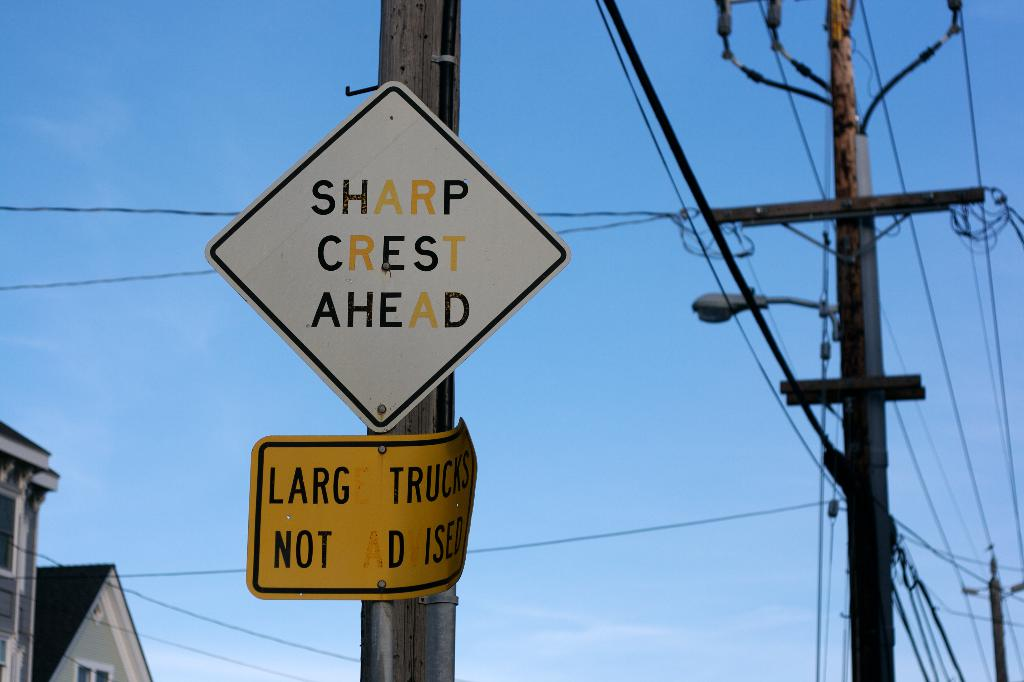What might be the significance of the two signs seen in the image? The 'Sharp Crest Ahead' sign alerts drivers to a sudden elevation change in the road, such as a steep hill, that could be obscured from view. The 'Large Trucks Not Advised' sign underneath suggests that the road conditions ahead may not be suitable for heavier or larger vehicles due to the crest, possibly due to limited maneuverability or stopping distance. 